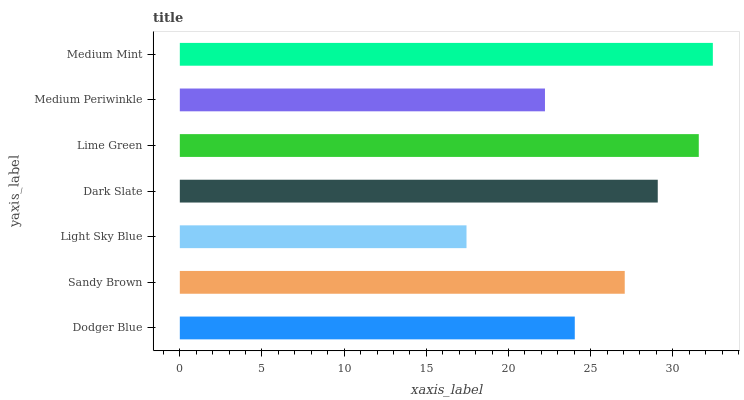Is Light Sky Blue the minimum?
Answer yes or no. Yes. Is Medium Mint the maximum?
Answer yes or no. Yes. Is Sandy Brown the minimum?
Answer yes or no. No. Is Sandy Brown the maximum?
Answer yes or no. No. Is Sandy Brown greater than Dodger Blue?
Answer yes or no. Yes. Is Dodger Blue less than Sandy Brown?
Answer yes or no. Yes. Is Dodger Blue greater than Sandy Brown?
Answer yes or no. No. Is Sandy Brown less than Dodger Blue?
Answer yes or no. No. Is Sandy Brown the high median?
Answer yes or no. Yes. Is Sandy Brown the low median?
Answer yes or no. Yes. Is Lime Green the high median?
Answer yes or no. No. Is Dark Slate the low median?
Answer yes or no. No. 